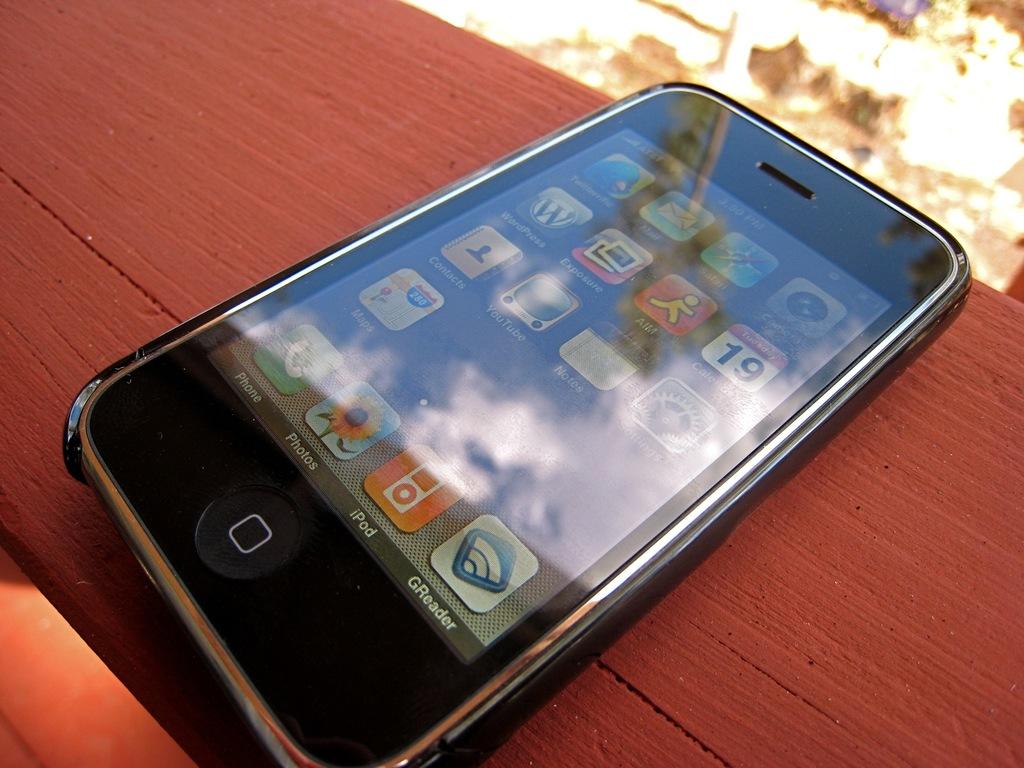What app is on the bottom right?
Your answer should be compact. Greader. 